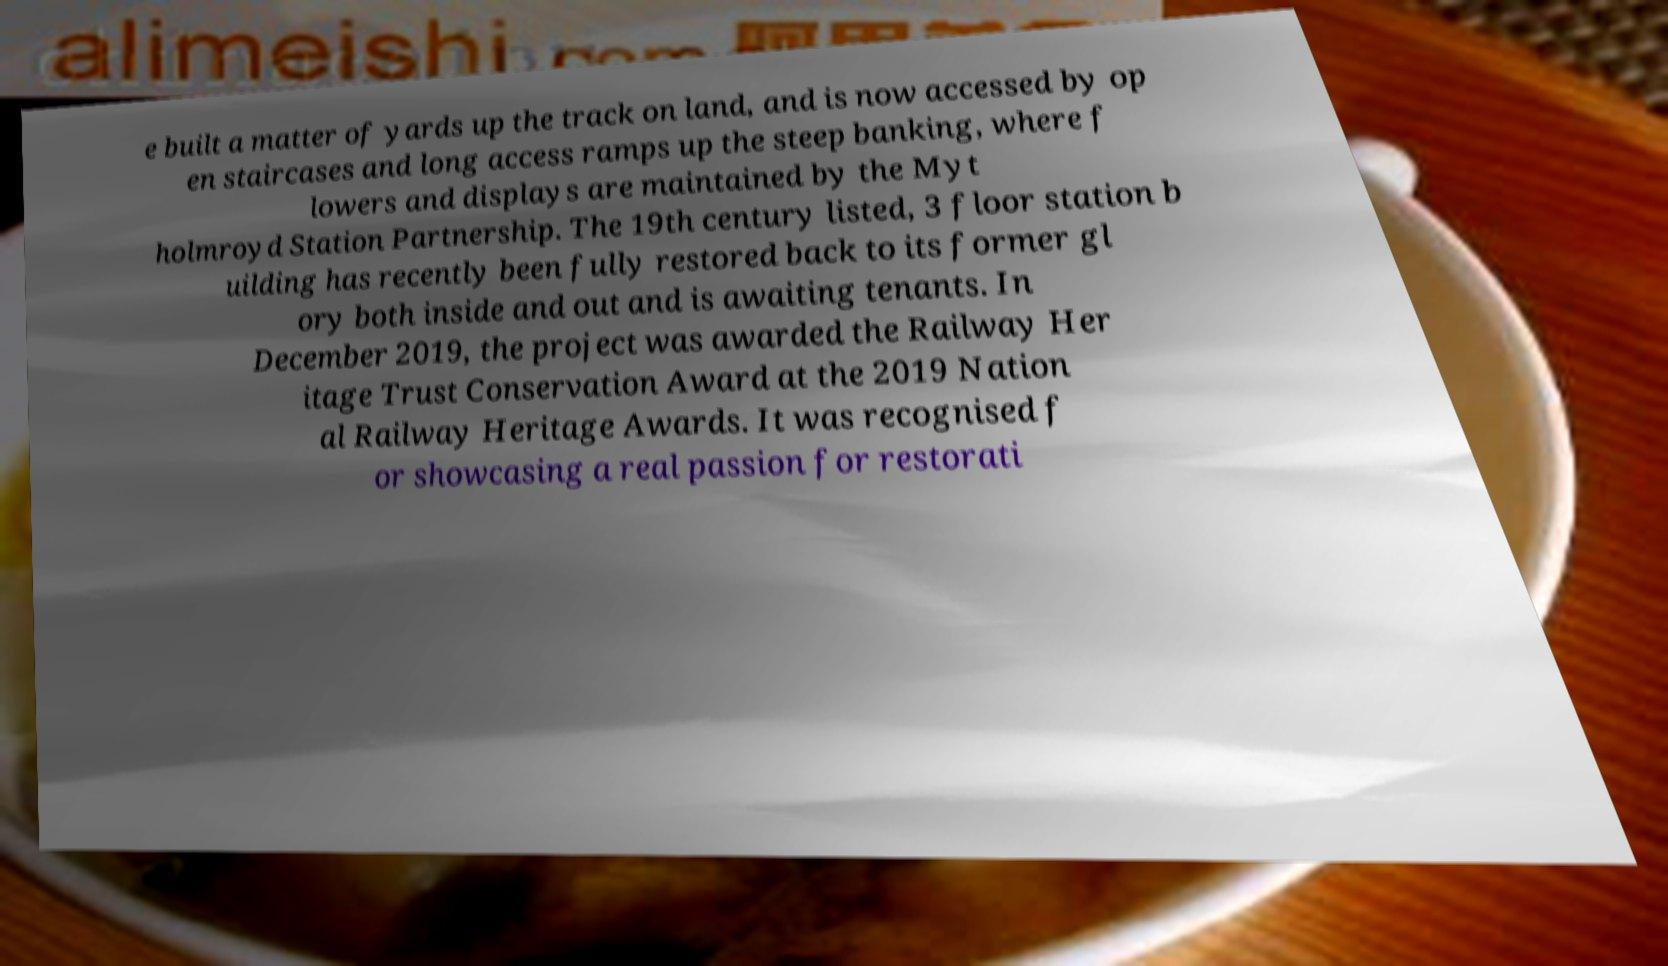Can you read and provide the text displayed in the image?This photo seems to have some interesting text. Can you extract and type it out for me? e built a matter of yards up the track on land, and is now accessed by op en staircases and long access ramps up the steep banking, where f lowers and displays are maintained by the Myt holmroyd Station Partnership. The 19th century listed, 3 floor station b uilding has recently been fully restored back to its former gl ory both inside and out and is awaiting tenants. In December 2019, the project was awarded the Railway Her itage Trust Conservation Award at the 2019 Nation al Railway Heritage Awards. It was recognised f or showcasing a real passion for restorati 